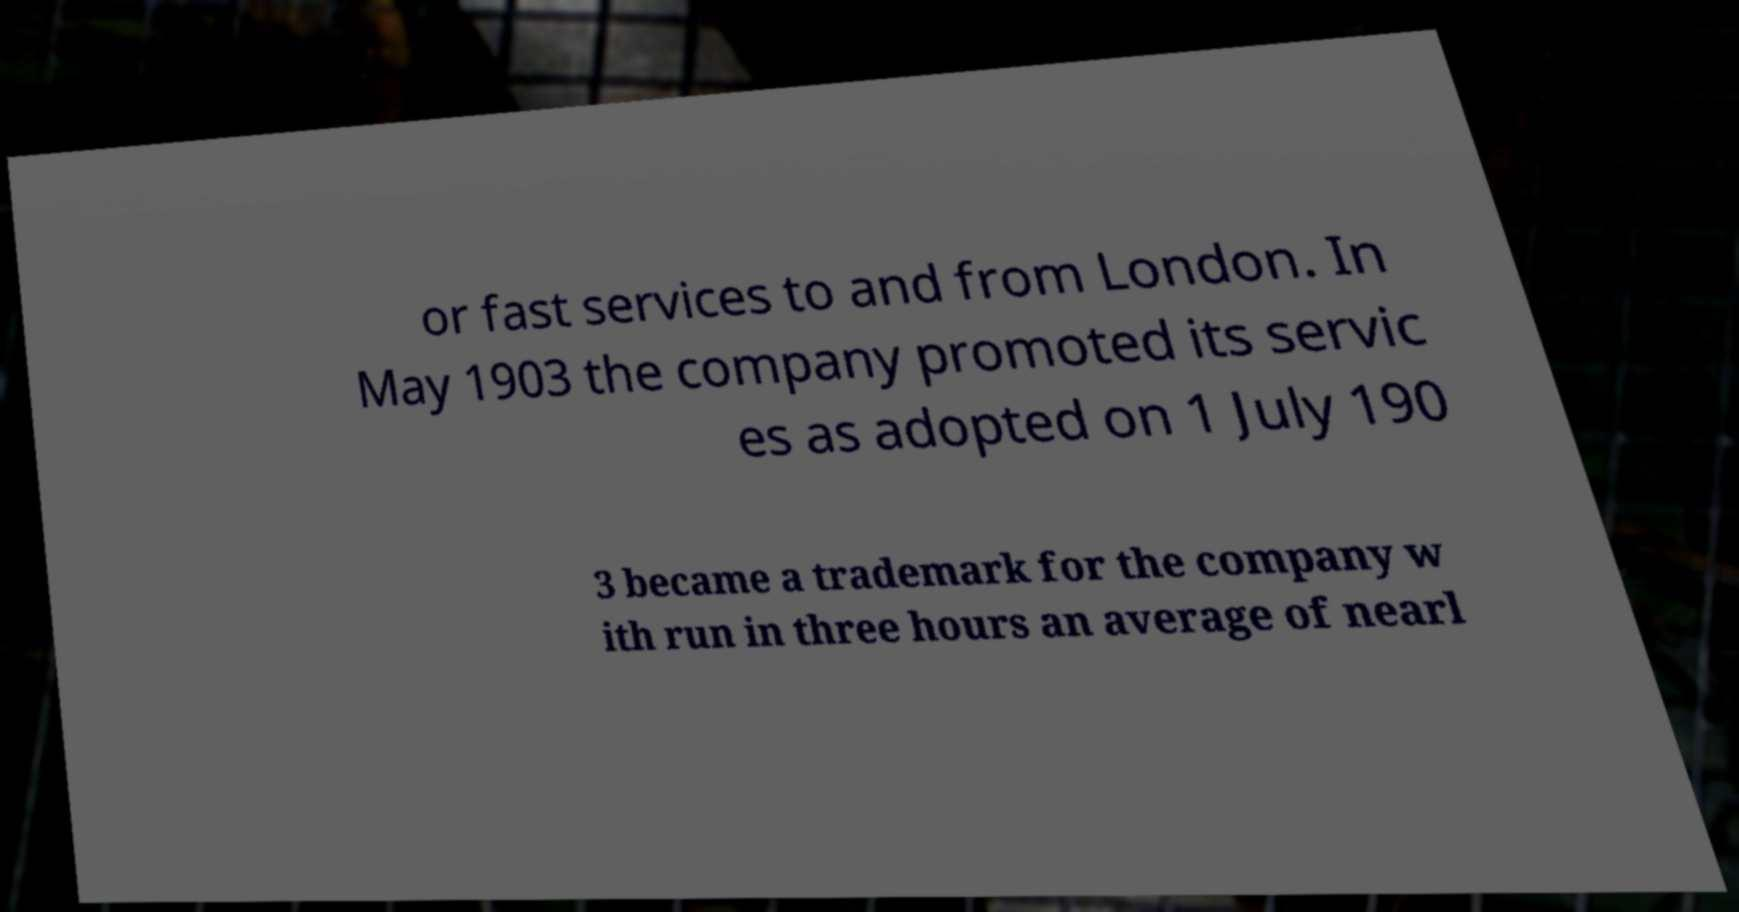For documentation purposes, I need the text within this image transcribed. Could you provide that? or fast services to and from London. In May 1903 the company promoted its servic es as adopted on 1 July 190 3 became a trademark for the company w ith run in three hours an average of nearl 